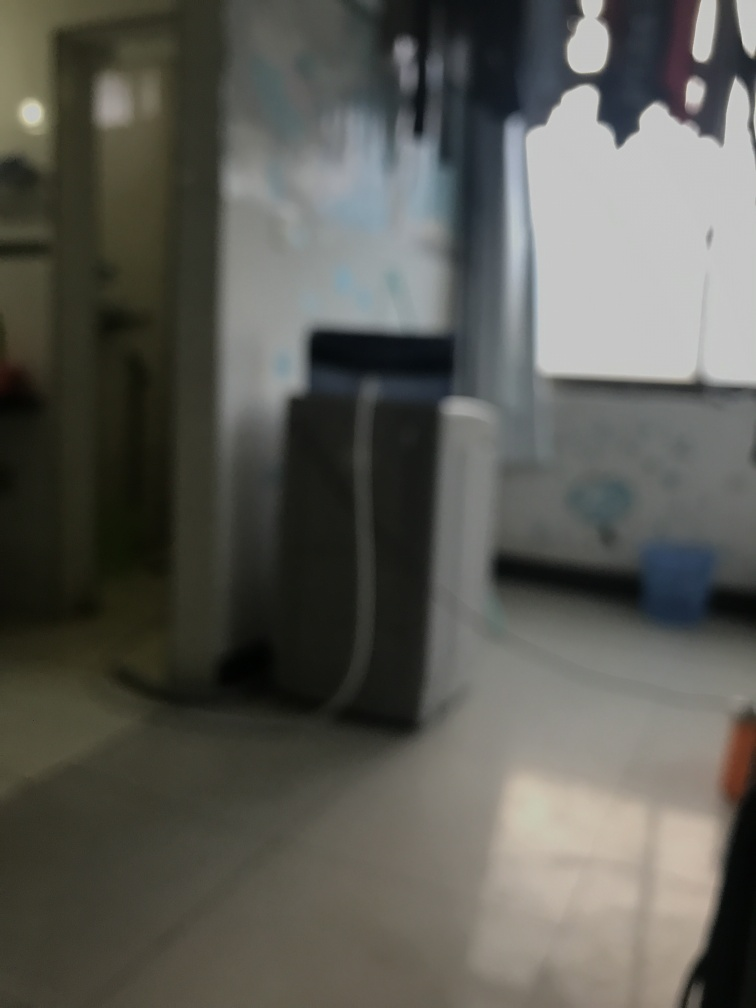Can you describe what looks visible in the background through the blurry entrance? Even though the details are obscured by the blur, you can vaguely make out that there appears to be some blue object or cover, which might be a doorway curtain, visible in the background. 